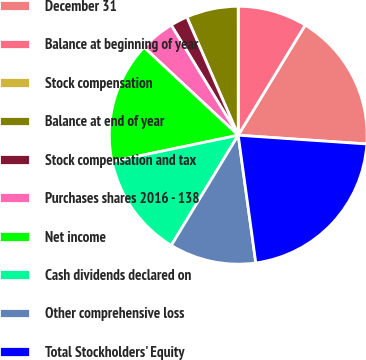Convert chart. <chart><loc_0><loc_0><loc_500><loc_500><pie_chart><fcel>December 31<fcel>Balance at beginning of year<fcel>Stock compensation<fcel>Balance at end of year<fcel>Stock compensation and tax<fcel>Purchases shares 2016 - 138<fcel>Net income<fcel>Cash dividends declared on<fcel>Other comprehensive loss<fcel>Total Stockholders' Equity<nl><fcel>17.39%<fcel>8.7%<fcel>0.0%<fcel>6.52%<fcel>2.18%<fcel>4.35%<fcel>15.22%<fcel>13.04%<fcel>10.87%<fcel>21.74%<nl></chart> 